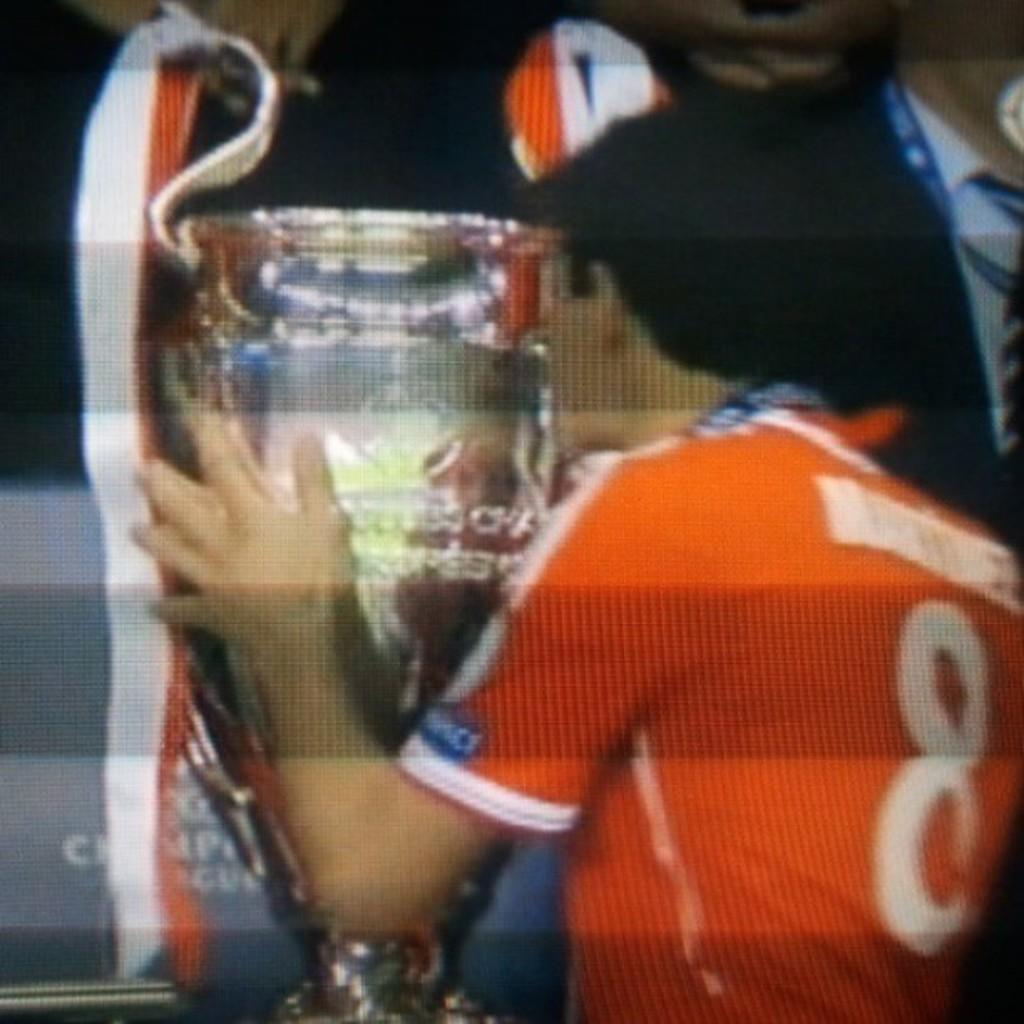<image>
Provide a brief description of the given image. a player with the number 8 on the back of their jersey 